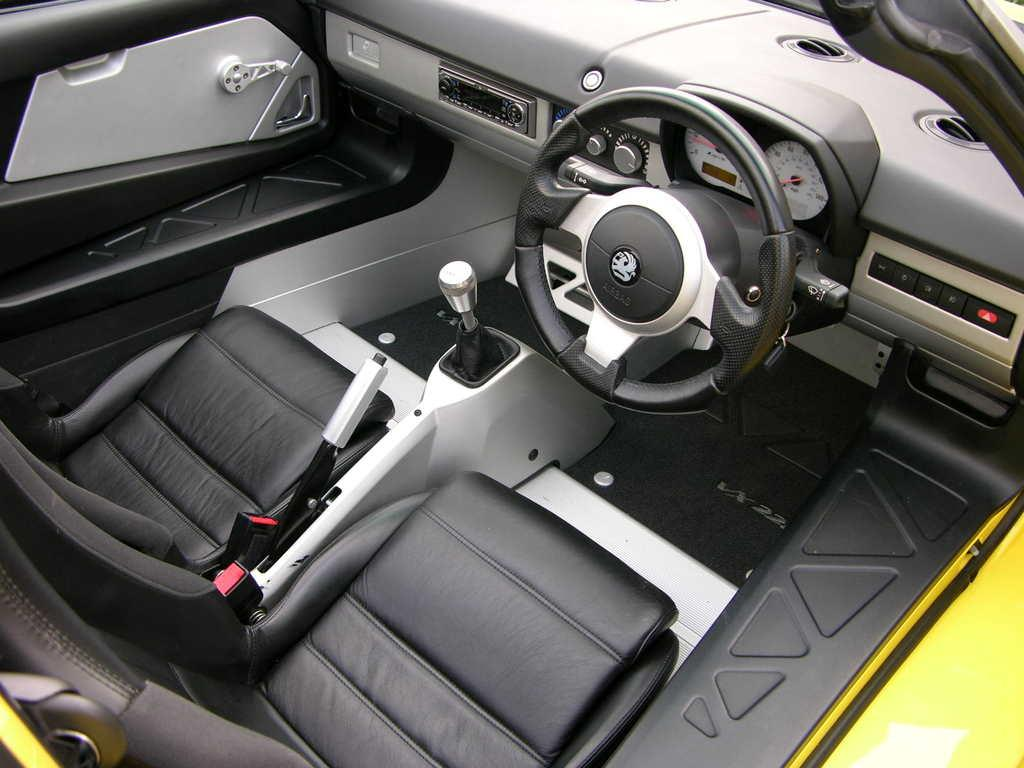What type of setting is depicted in the image? The image shows the inside of a vehicle. Can you describe any specific features or objects visible in the vehicle? Unfortunately, the provided facts do not mention any specific features or objects within the vehicle. What type of produce can be seen growing in the vehicle in the image? There is no produce visible in the vehicle in the image. Is the vehicle being used as a prison in the image? No, the vehicle is not being used as a prison in the image. What type of coal can be seen being transported in the vehicle in the image? There is no coal visible in the vehicle in the image. 